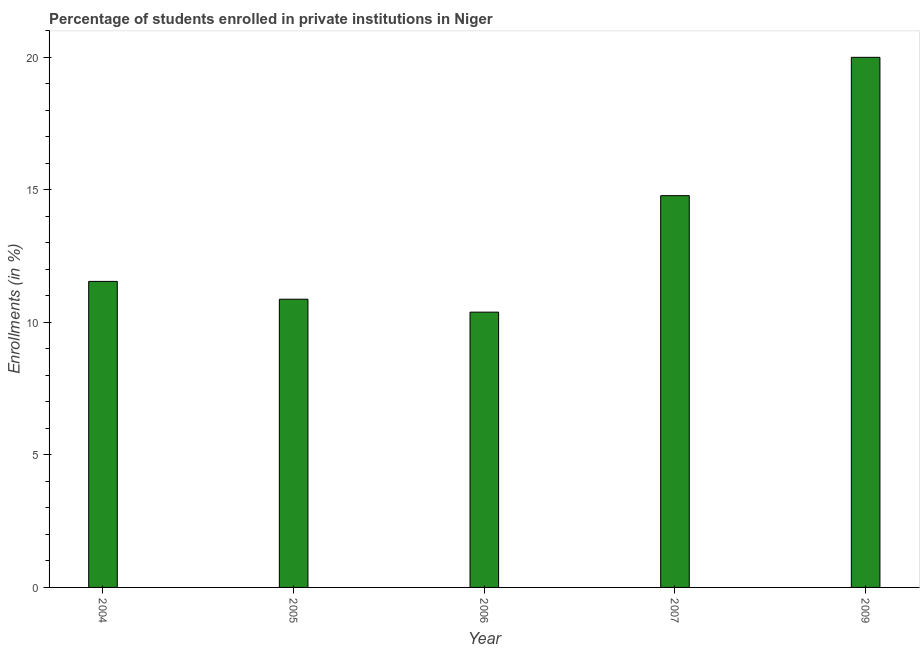Does the graph contain any zero values?
Your answer should be compact. No. Does the graph contain grids?
Provide a short and direct response. No. What is the title of the graph?
Make the answer very short. Percentage of students enrolled in private institutions in Niger. What is the label or title of the X-axis?
Make the answer very short. Year. What is the label or title of the Y-axis?
Provide a succinct answer. Enrollments (in %). What is the enrollments in private institutions in 2009?
Keep it short and to the point. 20.01. Across all years, what is the maximum enrollments in private institutions?
Offer a terse response. 20.01. Across all years, what is the minimum enrollments in private institutions?
Offer a very short reply. 10.39. What is the sum of the enrollments in private institutions?
Provide a short and direct response. 67.61. What is the difference between the enrollments in private institutions in 2004 and 2007?
Your response must be concise. -3.23. What is the average enrollments in private institutions per year?
Offer a terse response. 13.52. What is the median enrollments in private institutions?
Keep it short and to the point. 11.55. In how many years, is the enrollments in private institutions greater than 5 %?
Offer a terse response. 5. What is the ratio of the enrollments in private institutions in 2005 to that in 2007?
Offer a terse response. 0.74. What is the difference between the highest and the second highest enrollments in private institutions?
Provide a succinct answer. 5.22. Is the sum of the enrollments in private institutions in 2004 and 2005 greater than the maximum enrollments in private institutions across all years?
Make the answer very short. Yes. What is the difference between the highest and the lowest enrollments in private institutions?
Ensure brevity in your answer.  9.62. In how many years, is the enrollments in private institutions greater than the average enrollments in private institutions taken over all years?
Provide a short and direct response. 2. Are all the bars in the graph horizontal?
Provide a short and direct response. No. How many years are there in the graph?
Ensure brevity in your answer.  5. What is the difference between two consecutive major ticks on the Y-axis?
Your response must be concise. 5. What is the Enrollments (in %) in 2004?
Your answer should be compact. 11.55. What is the Enrollments (in %) of 2005?
Give a very brief answer. 10.88. What is the Enrollments (in %) in 2006?
Provide a succinct answer. 10.39. What is the Enrollments (in %) of 2007?
Make the answer very short. 14.78. What is the Enrollments (in %) in 2009?
Offer a terse response. 20.01. What is the difference between the Enrollments (in %) in 2004 and 2005?
Offer a very short reply. 0.67. What is the difference between the Enrollments (in %) in 2004 and 2006?
Ensure brevity in your answer.  1.16. What is the difference between the Enrollments (in %) in 2004 and 2007?
Your response must be concise. -3.24. What is the difference between the Enrollments (in %) in 2004 and 2009?
Offer a terse response. -8.46. What is the difference between the Enrollments (in %) in 2005 and 2006?
Offer a terse response. 0.49. What is the difference between the Enrollments (in %) in 2005 and 2007?
Offer a terse response. -3.91. What is the difference between the Enrollments (in %) in 2005 and 2009?
Your response must be concise. -9.13. What is the difference between the Enrollments (in %) in 2006 and 2007?
Your answer should be compact. -4.4. What is the difference between the Enrollments (in %) in 2006 and 2009?
Keep it short and to the point. -9.62. What is the difference between the Enrollments (in %) in 2007 and 2009?
Your response must be concise. -5.22. What is the ratio of the Enrollments (in %) in 2004 to that in 2005?
Offer a terse response. 1.06. What is the ratio of the Enrollments (in %) in 2004 to that in 2006?
Your response must be concise. 1.11. What is the ratio of the Enrollments (in %) in 2004 to that in 2007?
Offer a very short reply. 0.78. What is the ratio of the Enrollments (in %) in 2004 to that in 2009?
Keep it short and to the point. 0.58. What is the ratio of the Enrollments (in %) in 2005 to that in 2006?
Your answer should be compact. 1.05. What is the ratio of the Enrollments (in %) in 2005 to that in 2007?
Your answer should be very brief. 0.74. What is the ratio of the Enrollments (in %) in 2005 to that in 2009?
Keep it short and to the point. 0.54. What is the ratio of the Enrollments (in %) in 2006 to that in 2007?
Keep it short and to the point. 0.7. What is the ratio of the Enrollments (in %) in 2006 to that in 2009?
Offer a very short reply. 0.52. What is the ratio of the Enrollments (in %) in 2007 to that in 2009?
Ensure brevity in your answer.  0.74. 